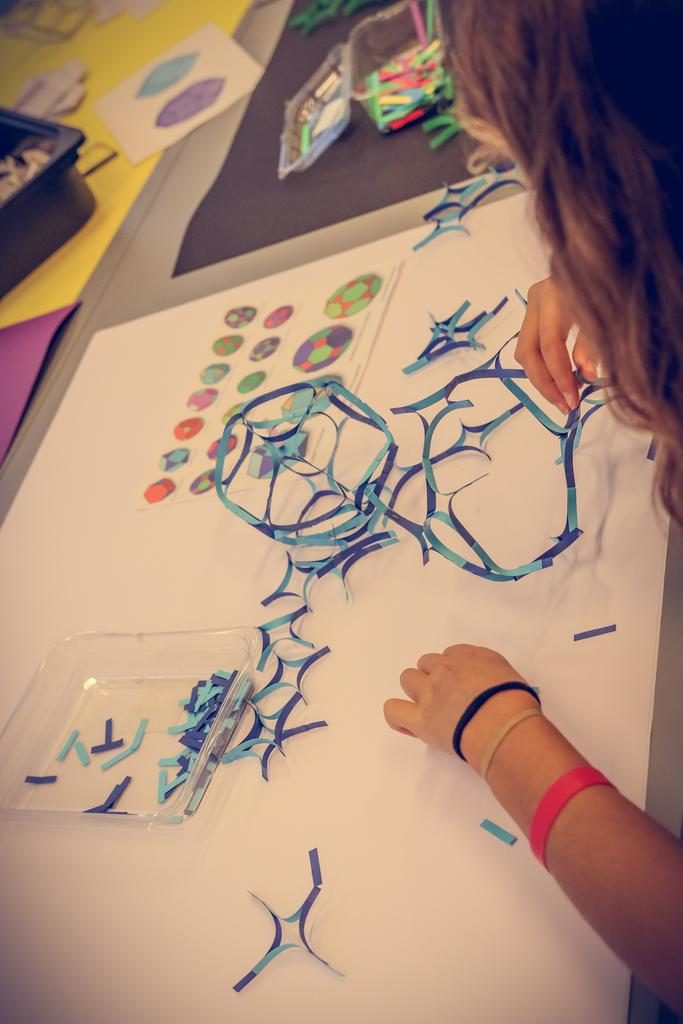What body part is visible in the image? There are a person's hands visible in the image. What is located on the table in the image? There are colorful objects on a table in the image. What type of flame can be seen in the image? There is no flame present in the image. What type of harmony is depicted in the image? There is no harmony depicted in the image; it features a person's hands and colorful objects on a table. 